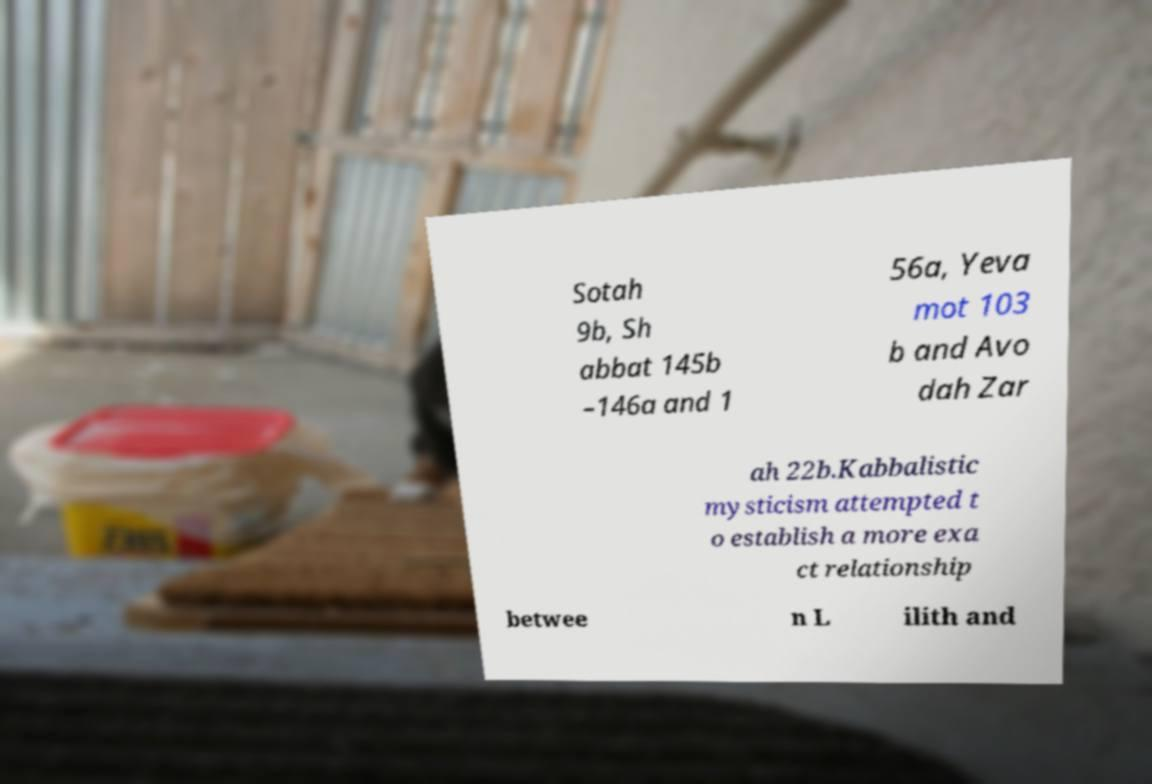There's text embedded in this image that I need extracted. Can you transcribe it verbatim? Sotah 9b, Sh abbat 145b –146a and 1 56a, Yeva mot 103 b and Avo dah Zar ah 22b.Kabbalistic mysticism attempted t o establish a more exa ct relationship betwee n L ilith and 